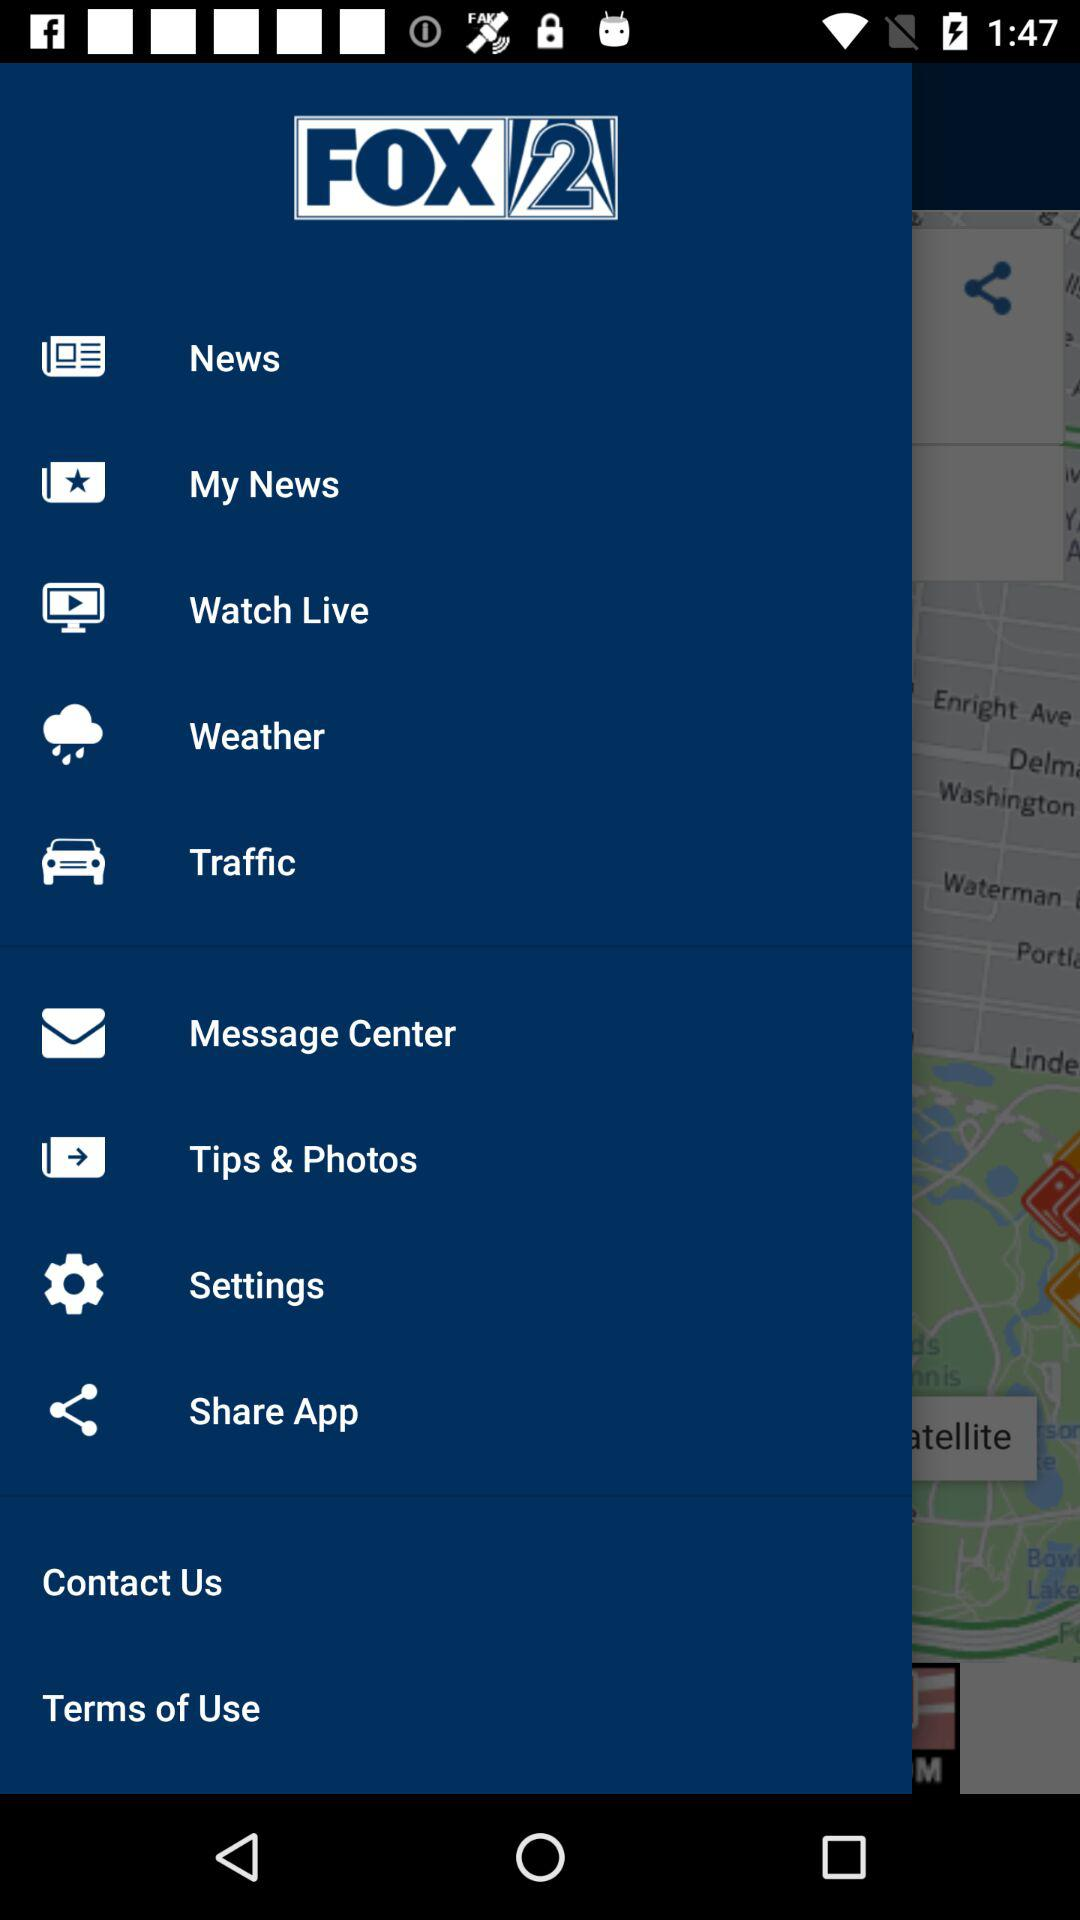What is the app name? The app name is "FOX 2". 